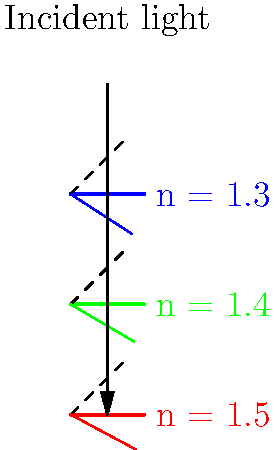As an art YouTuber experimenting with light refraction through paints, you observe that different colored paints bend light to varying degrees. The diagram shows incident light entering three paint layers with different refractive indices. If the angle of incidence is 45°, which color paint will refract the light the most, and what is the angle of refraction for this paint? To solve this problem, we'll use Snell's law and follow these steps:

1) Recall Snell's law: $n_1 \sin \theta_1 = n_2 \sin \theta_2$, where $n_1$ is the refractive index of air (approximately 1), $n_2$ is the refractive index of the paint, $\theta_1$ is the angle of incidence, and $\theta_2$ is the angle of refraction.

2) The angle of incidence is given as 45°. We need to find $\theta_2$ for each paint color.

3) Rearranging Snell's law: $\sin \theta_2 = \frac{n_1 \sin \theta_1}{n_2} = \frac{\sin 45°}{n_2}$

4) For each paint color:
   Red (n = 1.5): $\sin \theta_2 = \frac{\sin 45°}{1.5} = 0.4714$
   Green (n = 1.4): $\sin \theta_2 = \frac{\sin 45°}{1.4} = 0.5051$
   Blue (n = 1.3): $\sin \theta_2 = \frac{\sin 45°}{1.3} = 0.5439$

5) Taking the inverse sine (arcsin) of each result:
   Red: $\theta_2 = \arcsin(0.4714) = 28.1°$
   Green: $\theta_2 = \arcsin(0.5051) = 30.3°$
   Blue: $\theta_2 = \arcsin(0.5439) = 33.0°$

6) The paint that refracts the light the most is the one with the largest difference between the incident angle (45°) and the refracted angle. This is the red paint, with the smallest angle of refraction (28.1°).
Answer: Red paint; 28.1° 